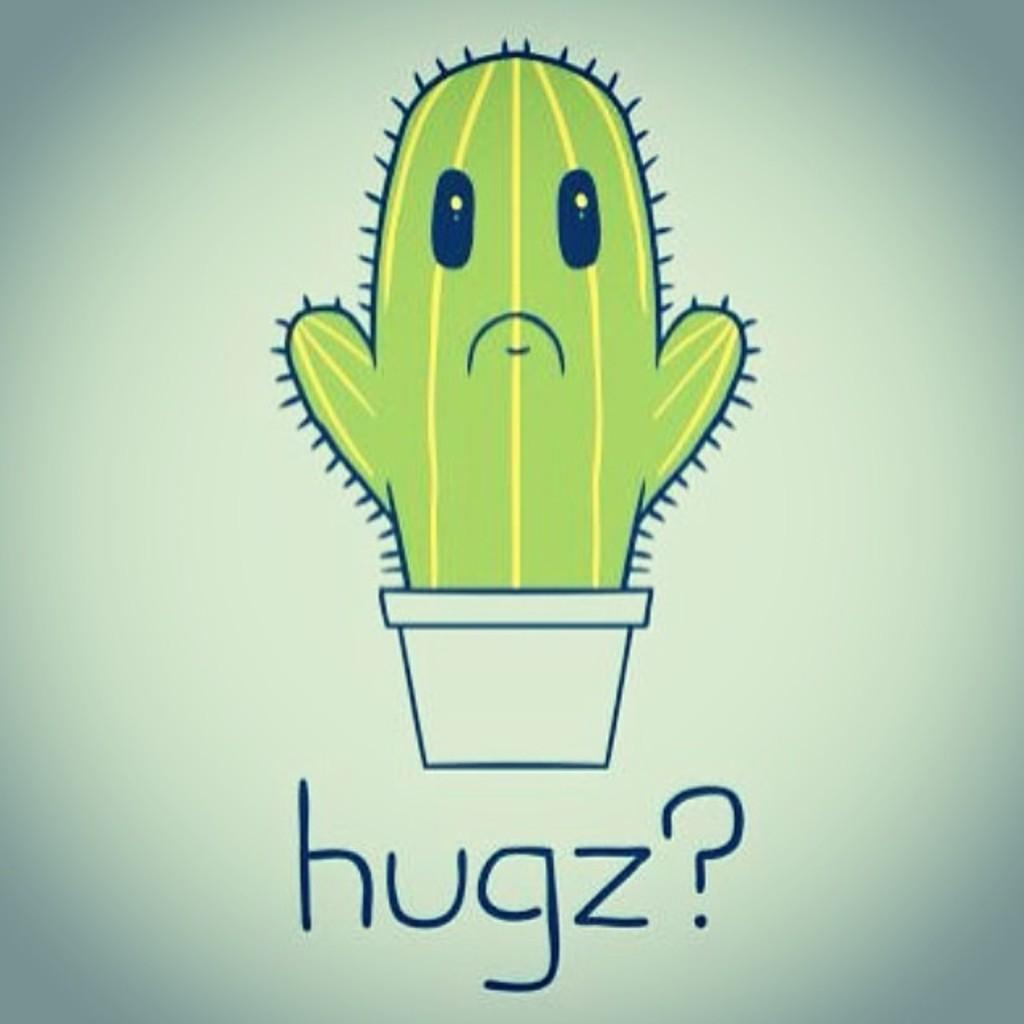What is the main subject of the image? The main subject of the image is a cartoon of a plant. How many trees are visible in the image? There are no trees visible in the image; it features a cartoon of a plant. What type of agreement is being made in the image? There is no agreement being made in the image; it features a cartoon of a plant. 